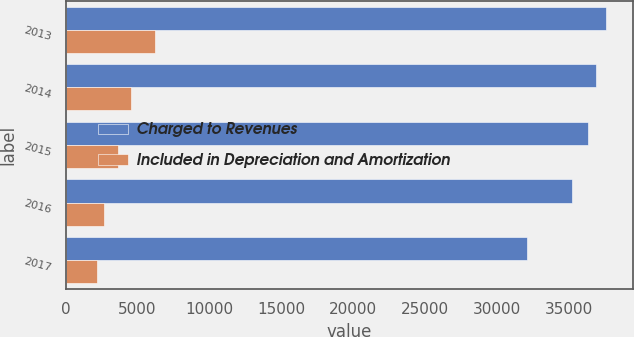Convert chart to OTSL. <chart><loc_0><loc_0><loc_500><loc_500><stacked_bar_chart><ecel><fcel>2013<fcel>2014<fcel>2015<fcel>2016<fcel>2017<nl><fcel>Charged to Revenues<fcel>37582<fcel>36861<fcel>36304<fcel>35187<fcel>32092<nl><fcel>Included in Depreciation and Amortization<fcel>6194<fcel>4556<fcel>3651<fcel>2662<fcel>2169<nl></chart> 